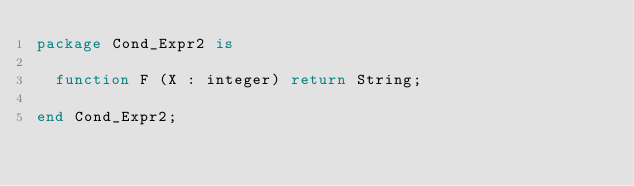<code> <loc_0><loc_0><loc_500><loc_500><_Ada_>package Cond_Expr2 is

  function F (X : integer) return String;

end Cond_Expr2;
</code> 